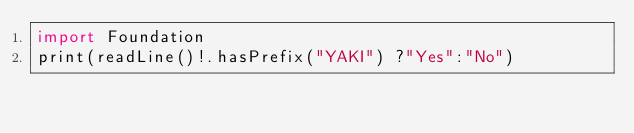Convert code to text. <code><loc_0><loc_0><loc_500><loc_500><_Swift_>import Foundation
print(readLine()!.hasPrefix("YAKI") ?"Yes":"No")</code> 